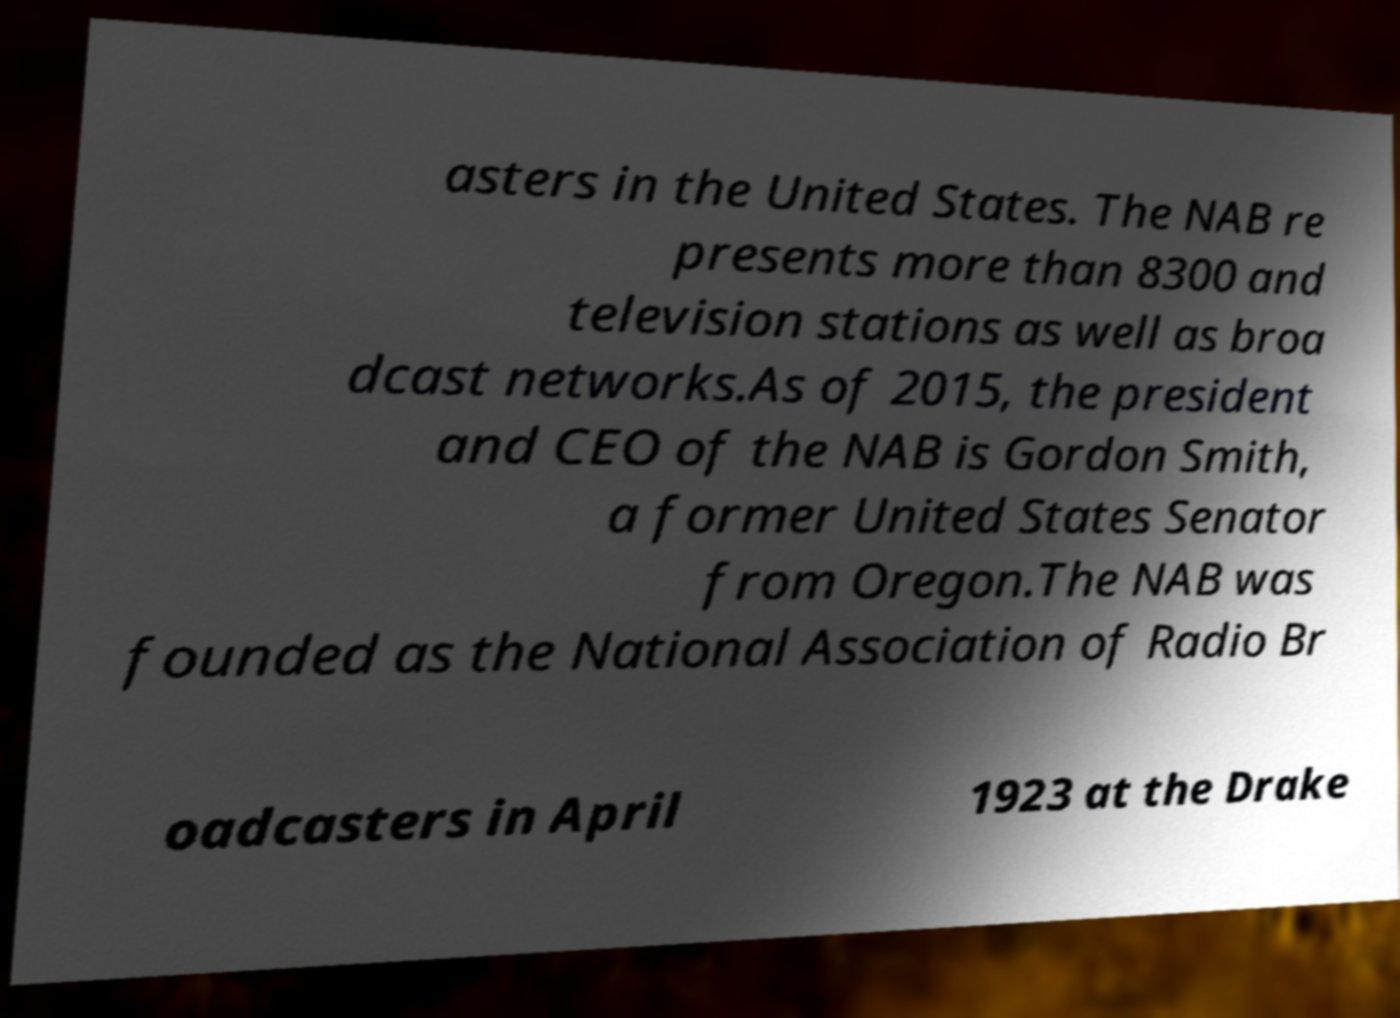Can you read and provide the text displayed in the image?This photo seems to have some interesting text. Can you extract and type it out for me? asters in the United States. The NAB re presents more than 8300 and television stations as well as broa dcast networks.As of 2015, the president and CEO of the NAB is Gordon Smith, a former United States Senator from Oregon.The NAB was founded as the National Association of Radio Br oadcasters in April 1923 at the Drake 